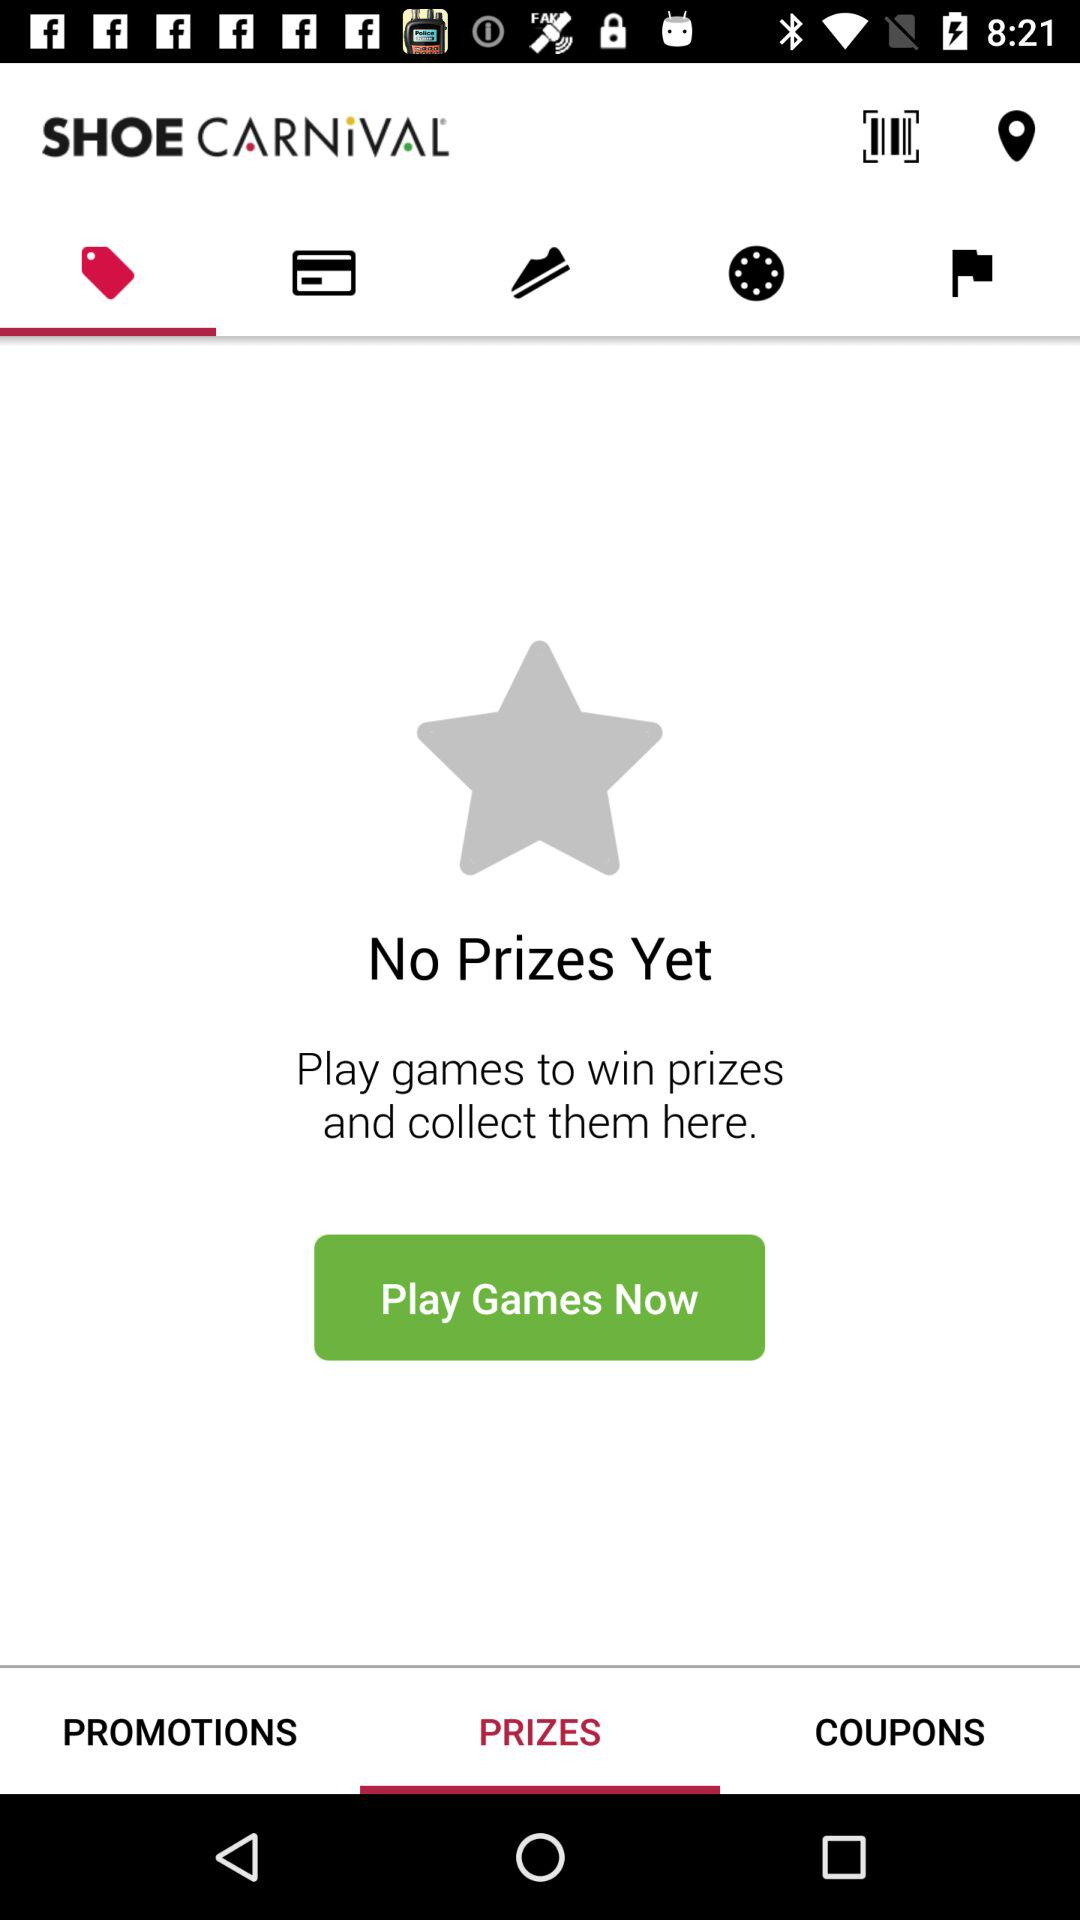Which tab am I on? You are on the "Deals" and "PRIZES" tabs. 